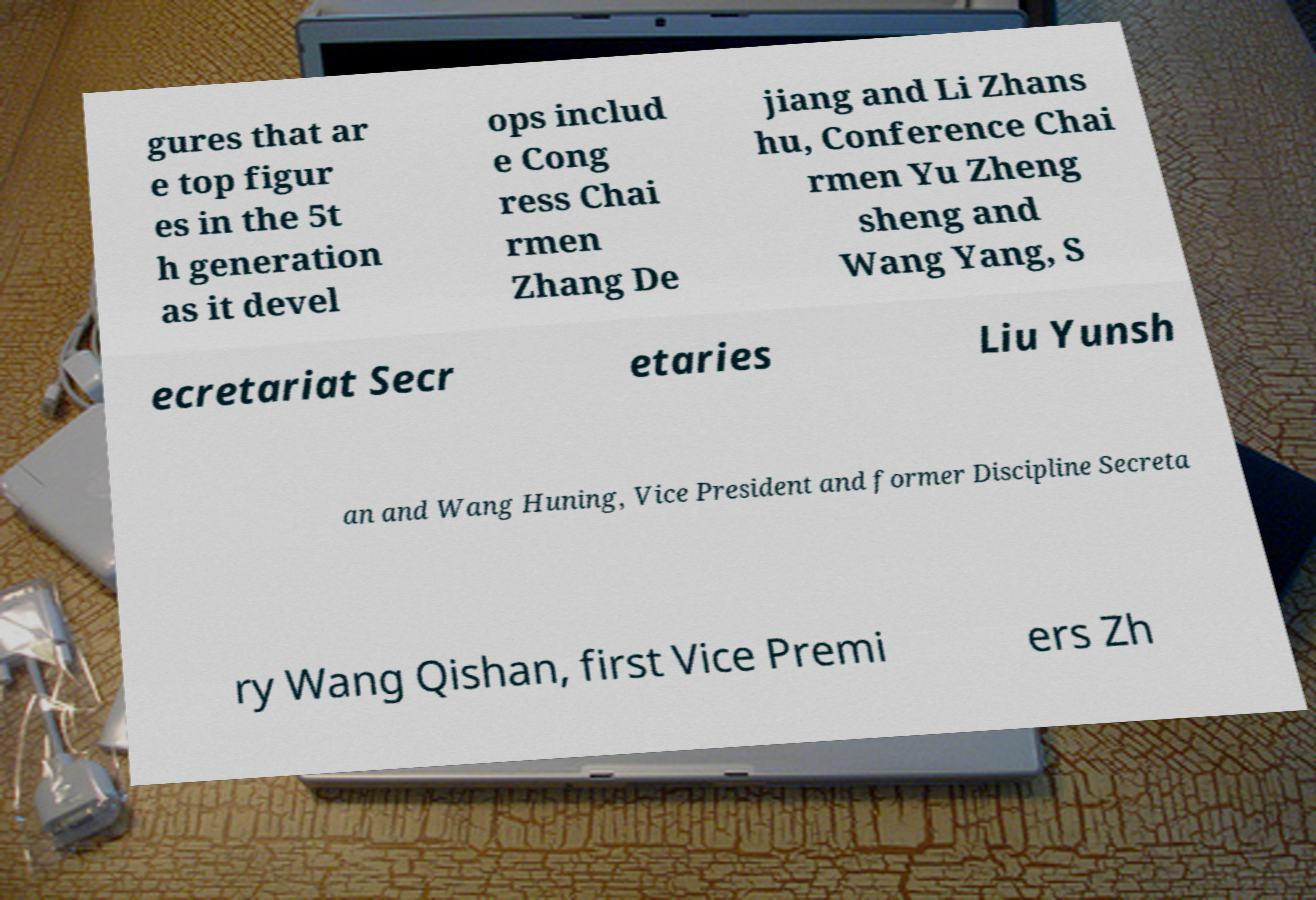For documentation purposes, I need the text within this image transcribed. Could you provide that? gures that ar e top figur es in the 5t h generation as it devel ops includ e Cong ress Chai rmen Zhang De jiang and Li Zhans hu, Conference Chai rmen Yu Zheng sheng and Wang Yang, S ecretariat Secr etaries Liu Yunsh an and Wang Huning, Vice President and former Discipline Secreta ry Wang Qishan, first Vice Premi ers Zh 